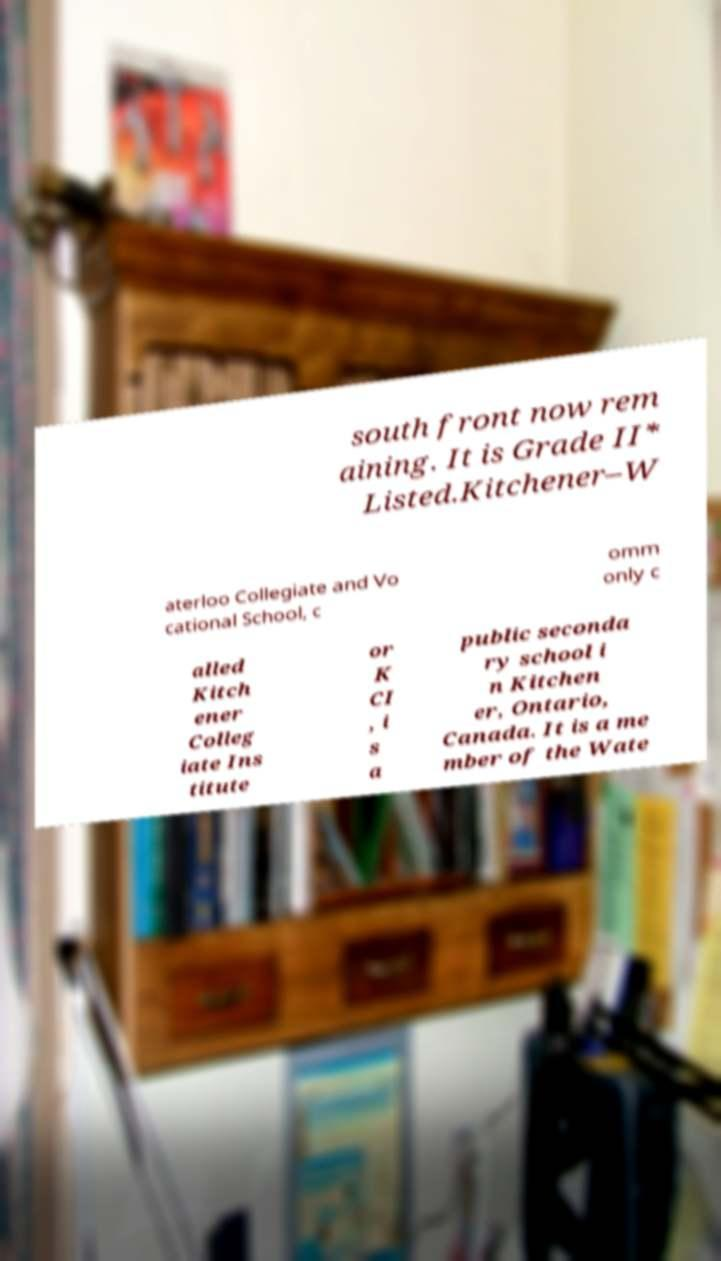Please read and relay the text visible in this image. What does it say? south front now rem aining. It is Grade II* Listed.Kitchener–W aterloo Collegiate and Vo cational School, c omm only c alled Kitch ener Colleg iate Ins titute or K CI , i s a public seconda ry school i n Kitchen er, Ontario, Canada. It is a me mber of the Wate 